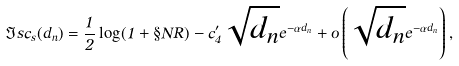<formula> <loc_0><loc_0><loc_500><loc_500>\Im s c _ { s } ( d _ { n } ) = \frac { 1 } { 2 } \log ( 1 + \S N R ) - c _ { 4 } ^ { \prime } \sqrt { d _ { n } } e ^ { - \alpha d _ { n } } + o \left ( \sqrt { d _ { n } } e ^ { - \alpha d _ { n } } \right ) ,</formula> 